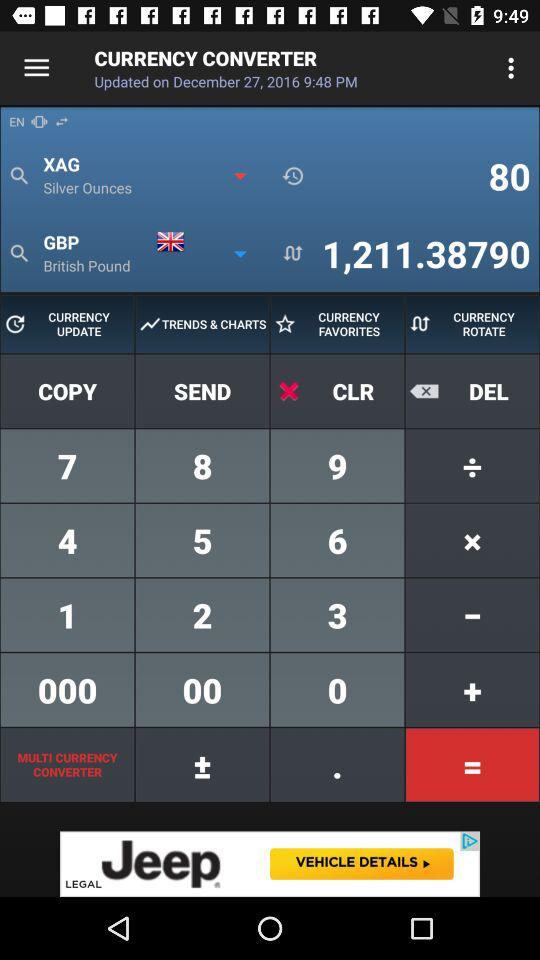On what date is the "Currency Converter" updated? The date is December 27, 2016. 